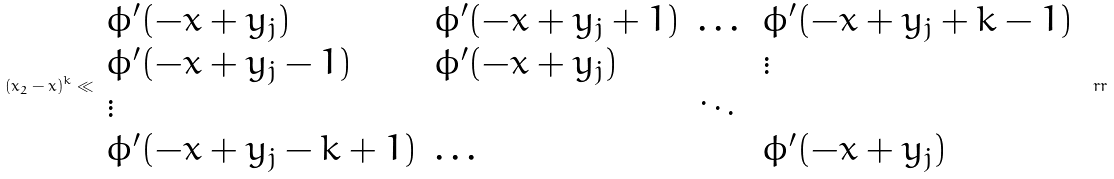<formula> <loc_0><loc_0><loc_500><loc_500>( x _ { 2 } - x ) ^ { k } \ll \begin{array} { l l l l } \phi ^ { \prime } ( - x + y _ { j } ) & \phi ^ { \prime } ( - x + y _ { j } + 1 ) & \dots & \phi ^ { \prime } ( - x + y _ { j } + k - 1 ) \\ \phi ^ { \prime } ( - x + y _ { j } - 1 ) & \phi ^ { \prime } ( - x + y _ { j } ) & & \vdots \\ \vdots & & \ddots & \\ \phi ^ { \prime } ( - x + y _ { j } - k + 1 ) & \dots & & \phi ^ { \prime } ( - x + y _ { j } ) \end{array} \ r r</formula> 